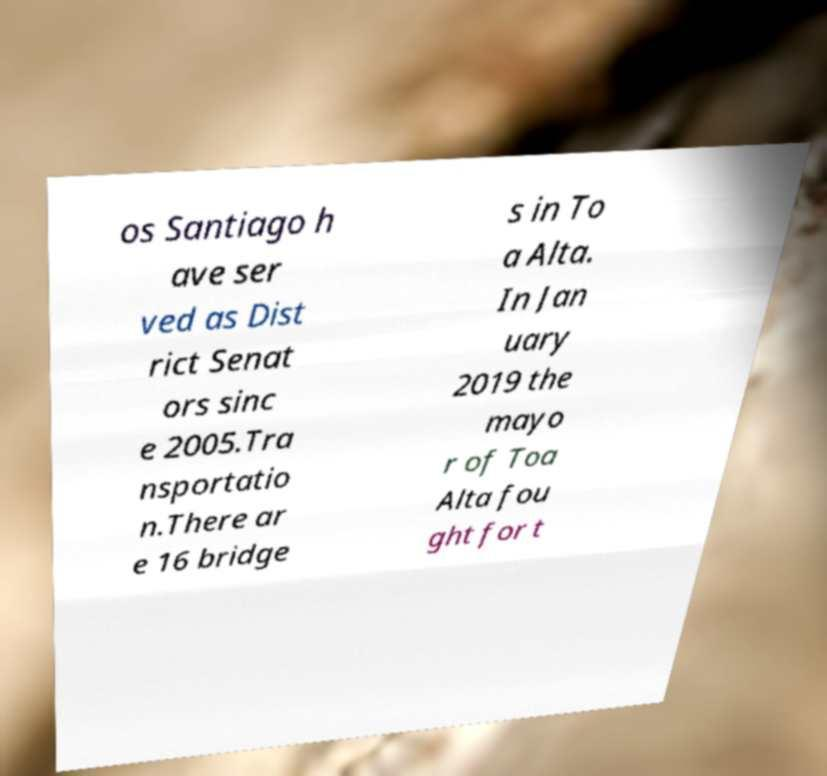Can you read and provide the text displayed in the image?This photo seems to have some interesting text. Can you extract and type it out for me? os Santiago h ave ser ved as Dist rict Senat ors sinc e 2005.Tra nsportatio n.There ar e 16 bridge s in To a Alta. In Jan uary 2019 the mayo r of Toa Alta fou ght for t 